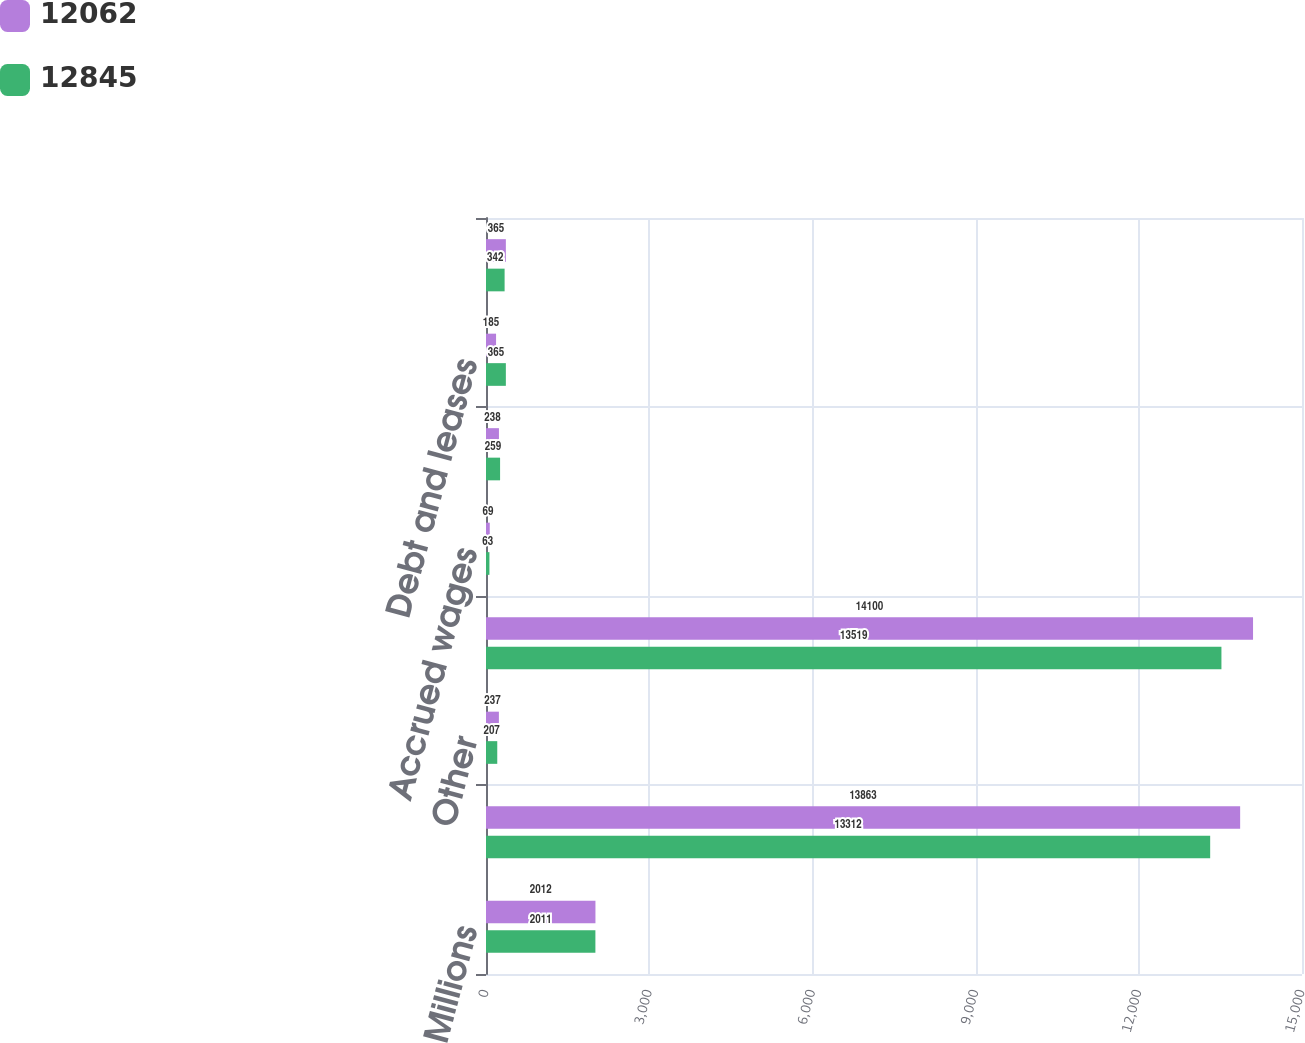Convert chart. <chart><loc_0><loc_0><loc_500><loc_500><stacked_bar_chart><ecel><fcel>Millions<fcel>Property<fcel>Other<fcel>Total deferred income tax<fcel>Accrued wages<fcel>Accrued casualty costs<fcel>Debt and leases<fcel>Retiree benefits<nl><fcel>12062<fcel>2012<fcel>13863<fcel>237<fcel>14100<fcel>69<fcel>238<fcel>185<fcel>365<nl><fcel>12845<fcel>2011<fcel>13312<fcel>207<fcel>13519<fcel>63<fcel>259<fcel>365<fcel>342<nl></chart> 